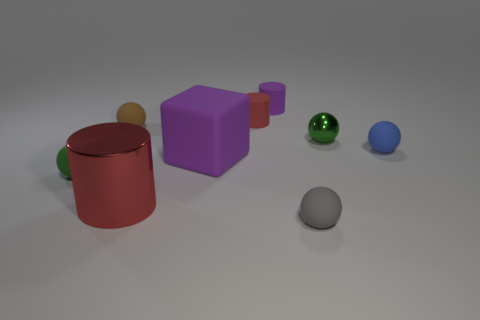Subtract all small blue rubber balls. How many balls are left? 4 Subtract all brown spheres. How many spheres are left? 4 Subtract all brown spheres. Subtract all yellow cylinders. How many spheres are left? 4 Add 1 big green cubes. How many objects exist? 10 Subtract all cylinders. How many objects are left? 6 Add 4 tiny blocks. How many tiny blocks exist? 4 Subtract 0 green cubes. How many objects are left? 9 Subtract all small gray balls. Subtract all green metallic spheres. How many objects are left? 7 Add 1 purple blocks. How many purple blocks are left? 2 